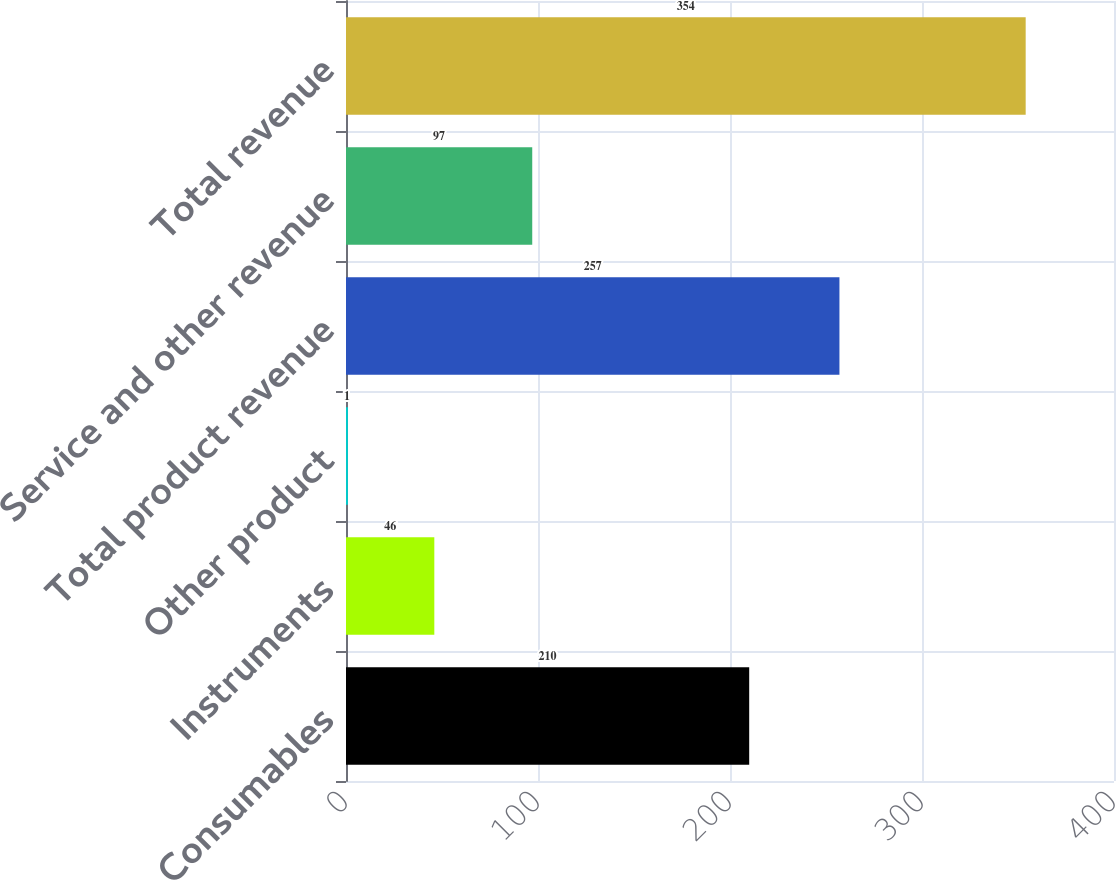Convert chart to OTSL. <chart><loc_0><loc_0><loc_500><loc_500><bar_chart><fcel>Consumables<fcel>Instruments<fcel>Other product<fcel>Total product revenue<fcel>Service and other revenue<fcel>Total revenue<nl><fcel>210<fcel>46<fcel>1<fcel>257<fcel>97<fcel>354<nl></chart> 